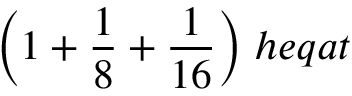Convert formula to latex. <formula><loc_0><loc_0><loc_500><loc_500>{ \left ( } 1 + { \frac { 1 } { 8 } } + { \frac { 1 } { 1 6 } } { \right ) } \, h e q a t</formula> 